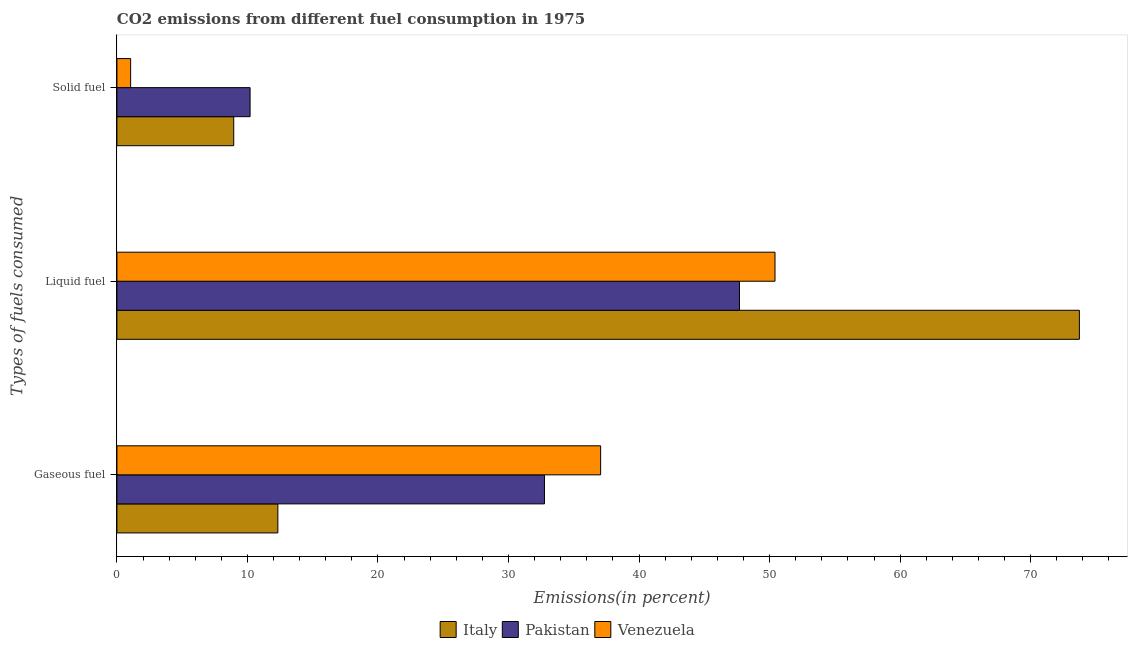How many different coloured bars are there?
Your answer should be very brief. 3. Are the number of bars per tick equal to the number of legend labels?
Your answer should be very brief. Yes. Are the number of bars on each tick of the Y-axis equal?
Offer a very short reply. Yes. How many bars are there on the 1st tick from the top?
Your answer should be compact. 3. What is the label of the 3rd group of bars from the top?
Your answer should be very brief. Gaseous fuel. What is the percentage of gaseous fuel emission in Pakistan?
Ensure brevity in your answer.  32.75. Across all countries, what is the maximum percentage of solid fuel emission?
Keep it short and to the point. 10.2. Across all countries, what is the minimum percentage of solid fuel emission?
Your answer should be compact. 1.05. In which country was the percentage of gaseous fuel emission maximum?
Offer a very short reply. Venezuela. In which country was the percentage of solid fuel emission minimum?
Provide a succinct answer. Venezuela. What is the total percentage of solid fuel emission in the graph?
Offer a terse response. 20.2. What is the difference between the percentage of gaseous fuel emission in Pakistan and that in Italy?
Offer a terse response. 20.42. What is the difference between the percentage of solid fuel emission in Italy and the percentage of liquid fuel emission in Pakistan?
Keep it short and to the point. -38.75. What is the average percentage of gaseous fuel emission per country?
Your answer should be very brief. 27.38. What is the difference between the percentage of liquid fuel emission and percentage of gaseous fuel emission in Italy?
Keep it short and to the point. 61.4. In how many countries, is the percentage of liquid fuel emission greater than 52 %?
Ensure brevity in your answer.  1. What is the ratio of the percentage of liquid fuel emission in Italy to that in Venezuela?
Keep it short and to the point. 1.46. Is the percentage of solid fuel emission in Italy less than that in Pakistan?
Offer a terse response. Yes. What is the difference between the highest and the second highest percentage of solid fuel emission?
Ensure brevity in your answer.  1.25. What is the difference between the highest and the lowest percentage of liquid fuel emission?
Offer a very short reply. 26.04. Is the sum of the percentage of solid fuel emission in Italy and Pakistan greater than the maximum percentage of gaseous fuel emission across all countries?
Keep it short and to the point. No. What does the 2nd bar from the top in Liquid fuel represents?
Your answer should be very brief. Pakistan. What does the 1st bar from the bottom in Liquid fuel represents?
Give a very brief answer. Italy. How many bars are there?
Ensure brevity in your answer.  9. How many countries are there in the graph?
Provide a short and direct response. 3. What is the difference between two consecutive major ticks on the X-axis?
Offer a terse response. 10. Are the values on the major ticks of X-axis written in scientific E-notation?
Give a very brief answer. No. Does the graph contain any zero values?
Make the answer very short. No. How many legend labels are there?
Provide a short and direct response. 3. What is the title of the graph?
Your answer should be compact. CO2 emissions from different fuel consumption in 1975. Does "Latin America(all income levels)" appear as one of the legend labels in the graph?
Your response must be concise. No. What is the label or title of the X-axis?
Your answer should be compact. Emissions(in percent). What is the label or title of the Y-axis?
Your answer should be compact. Types of fuels consumed. What is the Emissions(in percent) of Italy in Gaseous fuel?
Provide a short and direct response. 12.33. What is the Emissions(in percent) in Pakistan in Gaseous fuel?
Keep it short and to the point. 32.75. What is the Emissions(in percent) in Venezuela in Gaseous fuel?
Provide a succinct answer. 37.06. What is the Emissions(in percent) of Italy in Liquid fuel?
Your answer should be very brief. 73.73. What is the Emissions(in percent) in Pakistan in Liquid fuel?
Provide a succinct answer. 47.69. What is the Emissions(in percent) in Venezuela in Liquid fuel?
Your answer should be very brief. 50.42. What is the Emissions(in percent) of Italy in Solid fuel?
Make the answer very short. 8.95. What is the Emissions(in percent) of Pakistan in Solid fuel?
Offer a terse response. 10.2. What is the Emissions(in percent) in Venezuela in Solid fuel?
Ensure brevity in your answer.  1.05. Across all Types of fuels consumed, what is the maximum Emissions(in percent) in Italy?
Keep it short and to the point. 73.73. Across all Types of fuels consumed, what is the maximum Emissions(in percent) in Pakistan?
Make the answer very short. 47.69. Across all Types of fuels consumed, what is the maximum Emissions(in percent) of Venezuela?
Provide a succinct answer. 50.42. Across all Types of fuels consumed, what is the minimum Emissions(in percent) in Italy?
Give a very brief answer. 8.95. Across all Types of fuels consumed, what is the minimum Emissions(in percent) in Pakistan?
Offer a very short reply. 10.2. Across all Types of fuels consumed, what is the minimum Emissions(in percent) in Venezuela?
Make the answer very short. 1.05. What is the total Emissions(in percent) of Italy in the graph?
Give a very brief answer. 95.01. What is the total Emissions(in percent) in Pakistan in the graph?
Provide a succinct answer. 90.65. What is the total Emissions(in percent) of Venezuela in the graph?
Keep it short and to the point. 88.53. What is the difference between the Emissions(in percent) in Italy in Gaseous fuel and that in Liquid fuel?
Keep it short and to the point. -61.4. What is the difference between the Emissions(in percent) of Pakistan in Gaseous fuel and that in Liquid fuel?
Offer a terse response. -14.94. What is the difference between the Emissions(in percent) in Venezuela in Gaseous fuel and that in Liquid fuel?
Your answer should be very brief. -13.36. What is the difference between the Emissions(in percent) of Italy in Gaseous fuel and that in Solid fuel?
Your answer should be compact. 3.38. What is the difference between the Emissions(in percent) of Pakistan in Gaseous fuel and that in Solid fuel?
Provide a succinct answer. 22.55. What is the difference between the Emissions(in percent) of Venezuela in Gaseous fuel and that in Solid fuel?
Offer a very short reply. 36.01. What is the difference between the Emissions(in percent) of Italy in Liquid fuel and that in Solid fuel?
Ensure brevity in your answer.  64.79. What is the difference between the Emissions(in percent) in Pakistan in Liquid fuel and that in Solid fuel?
Your answer should be very brief. 37.49. What is the difference between the Emissions(in percent) of Venezuela in Liquid fuel and that in Solid fuel?
Offer a terse response. 49.37. What is the difference between the Emissions(in percent) in Italy in Gaseous fuel and the Emissions(in percent) in Pakistan in Liquid fuel?
Keep it short and to the point. -35.36. What is the difference between the Emissions(in percent) of Italy in Gaseous fuel and the Emissions(in percent) of Venezuela in Liquid fuel?
Your answer should be compact. -38.09. What is the difference between the Emissions(in percent) in Pakistan in Gaseous fuel and the Emissions(in percent) in Venezuela in Liquid fuel?
Make the answer very short. -17.66. What is the difference between the Emissions(in percent) in Italy in Gaseous fuel and the Emissions(in percent) in Pakistan in Solid fuel?
Provide a succinct answer. 2.13. What is the difference between the Emissions(in percent) in Italy in Gaseous fuel and the Emissions(in percent) in Venezuela in Solid fuel?
Keep it short and to the point. 11.28. What is the difference between the Emissions(in percent) in Pakistan in Gaseous fuel and the Emissions(in percent) in Venezuela in Solid fuel?
Offer a very short reply. 31.7. What is the difference between the Emissions(in percent) of Italy in Liquid fuel and the Emissions(in percent) of Pakistan in Solid fuel?
Offer a very short reply. 63.53. What is the difference between the Emissions(in percent) in Italy in Liquid fuel and the Emissions(in percent) in Venezuela in Solid fuel?
Keep it short and to the point. 72.68. What is the difference between the Emissions(in percent) in Pakistan in Liquid fuel and the Emissions(in percent) in Venezuela in Solid fuel?
Make the answer very short. 46.64. What is the average Emissions(in percent) in Italy per Types of fuels consumed?
Offer a terse response. 31.67. What is the average Emissions(in percent) in Pakistan per Types of fuels consumed?
Keep it short and to the point. 30.22. What is the average Emissions(in percent) in Venezuela per Types of fuels consumed?
Your answer should be compact. 29.51. What is the difference between the Emissions(in percent) of Italy and Emissions(in percent) of Pakistan in Gaseous fuel?
Offer a terse response. -20.42. What is the difference between the Emissions(in percent) in Italy and Emissions(in percent) in Venezuela in Gaseous fuel?
Make the answer very short. -24.73. What is the difference between the Emissions(in percent) in Pakistan and Emissions(in percent) in Venezuela in Gaseous fuel?
Provide a short and direct response. -4.3. What is the difference between the Emissions(in percent) in Italy and Emissions(in percent) in Pakistan in Liquid fuel?
Provide a succinct answer. 26.04. What is the difference between the Emissions(in percent) in Italy and Emissions(in percent) in Venezuela in Liquid fuel?
Ensure brevity in your answer.  23.32. What is the difference between the Emissions(in percent) of Pakistan and Emissions(in percent) of Venezuela in Liquid fuel?
Make the answer very short. -2.72. What is the difference between the Emissions(in percent) of Italy and Emissions(in percent) of Pakistan in Solid fuel?
Your response must be concise. -1.25. What is the difference between the Emissions(in percent) of Italy and Emissions(in percent) of Venezuela in Solid fuel?
Keep it short and to the point. 7.9. What is the difference between the Emissions(in percent) of Pakistan and Emissions(in percent) of Venezuela in Solid fuel?
Provide a succinct answer. 9.15. What is the ratio of the Emissions(in percent) of Italy in Gaseous fuel to that in Liquid fuel?
Your response must be concise. 0.17. What is the ratio of the Emissions(in percent) of Pakistan in Gaseous fuel to that in Liquid fuel?
Offer a terse response. 0.69. What is the ratio of the Emissions(in percent) in Venezuela in Gaseous fuel to that in Liquid fuel?
Ensure brevity in your answer.  0.73. What is the ratio of the Emissions(in percent) in Italy in Gaseous fuel to that in Solid fuel?
Your response must be concise. 1.38. What is the ratio of the Emissions(in percent) in Pakistan in Gaseous fuel to that in Solid fuel?
Your answer should be compact. 3.21. What is the ratio of the Emissions(in percent) of Venezuela in Gaseous fuel to that in Solid fuel?
Your response must be concise. 35.24. What is the ratio of the Emissions(in percent) in Italy in Liquid fuel to that in Solid fuel?
Offer a terse response. 8.24. What is the ratio of the Emissions(in percent) of Pakistan in Liquid fuel to that in Solid fuel?
Provide a succinct answer. 4.67. What is the ratio of the Emissions(in percent) in Venezuela in Liquid fuel to that in Solid fuel?
Your answer should be compact. 47.95. What is the difference between the highest and the second highest Emissions(in percent) in Italy?
Ensure brevity in your answer.  61.4. What is the difference between the highest and the second highest Emissions(in percent) in Pakistan?
Your response must be concise. 14.94. What is the difference between the highest and the second highest Emissions(in percent) of Venezuela?
Make the answer very short. 13.36. What is the difference between the highest and the lowest Emissions(in percent) of Italy?
Offer a very short reply. 64.79. What is the difference between the highest and the lowest Emissions(in percent) of Pakistan?
Your answer should be compact. 37.49. What is the difference between the highest and the lowest Emissions(in percent) in Venezuela?
Provide a short and direct response. 49.37. 